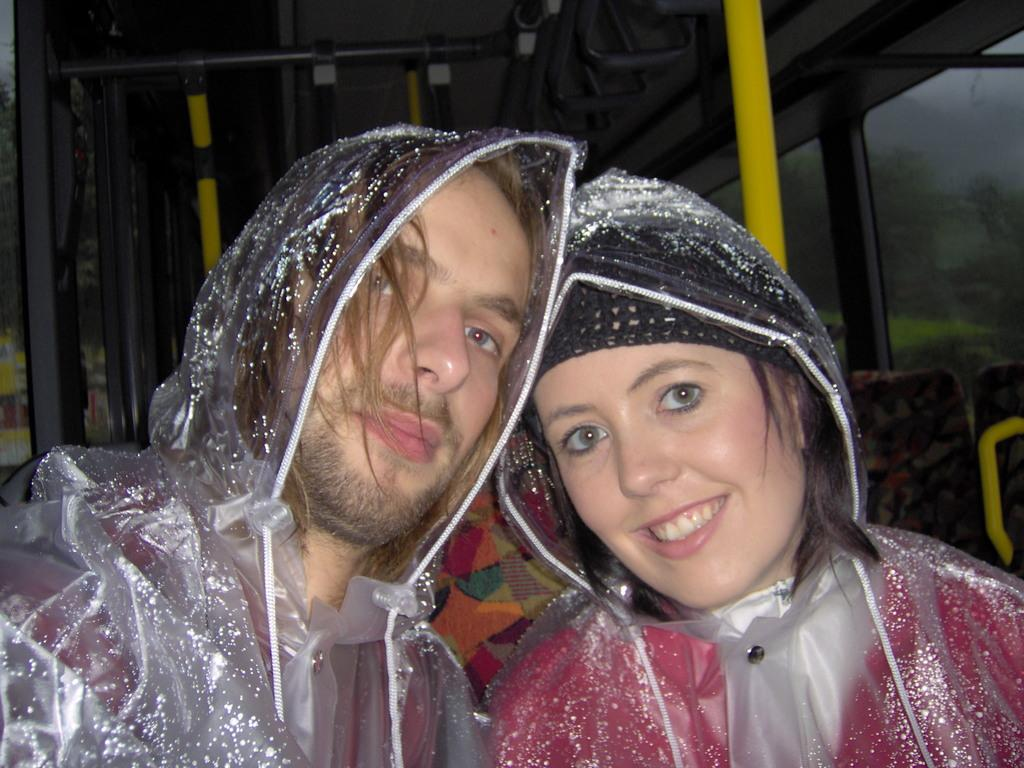Who can be seen in the foreground of the image? There is a man and a woman in the foreground of the image. What are the man and woman wearing? The man and woman are wearing raincoats. What can be seen in the background of the image? In the background, there are rods visible, as well as glass windows and holders. What type of thread is being used to sew the pail in the image? There is no pail present in the image, so there is no thread being used to sew it. 